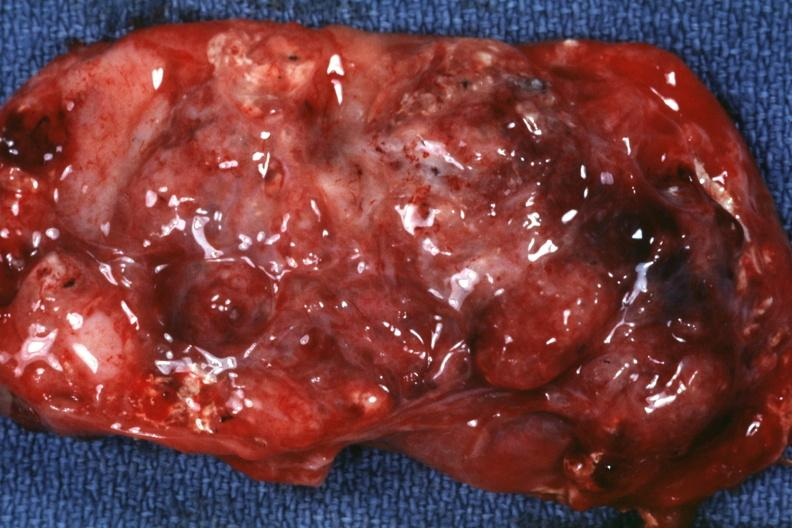what is present?
Answer the question using a single word or phrase. Sacrococcygeal teratoma 